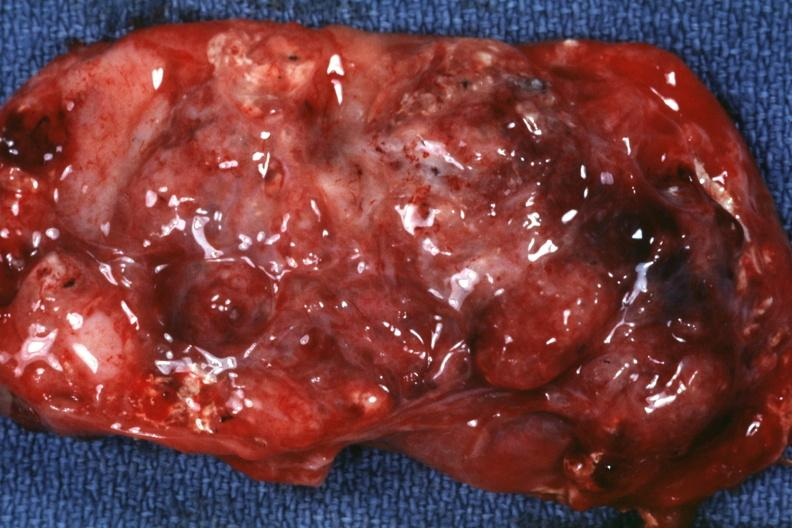what is present?
Answer the question using a single word or phrase. Sacrococcygeal teratoma 